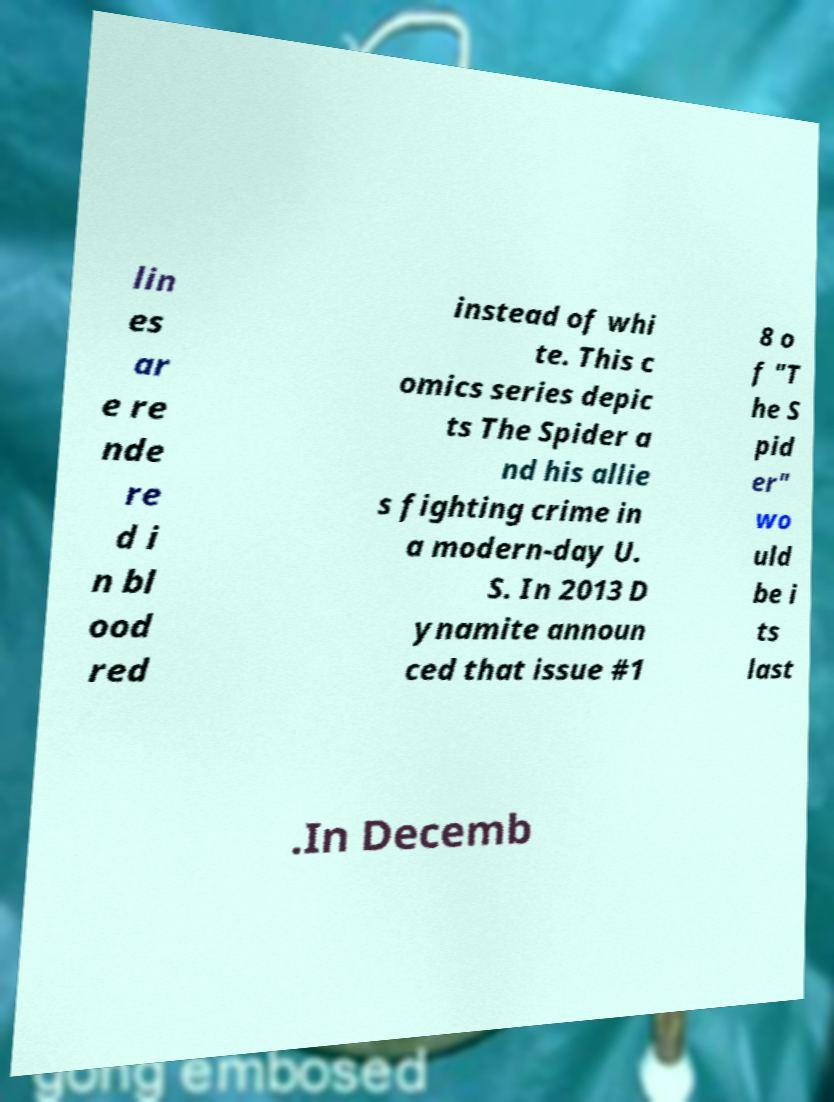I need the written content from this picture converted into text. Can you do that? lin es ar e re nde re d i n bl ood red instead of whi te. This c omics series depic ts The Spider a nd his allie s fighting crime in a modern-day U. S. In 2013 D ynamite announ ced that issue #1 8 o f "T he S pid er" wo uld be i ts last .In Decemb 